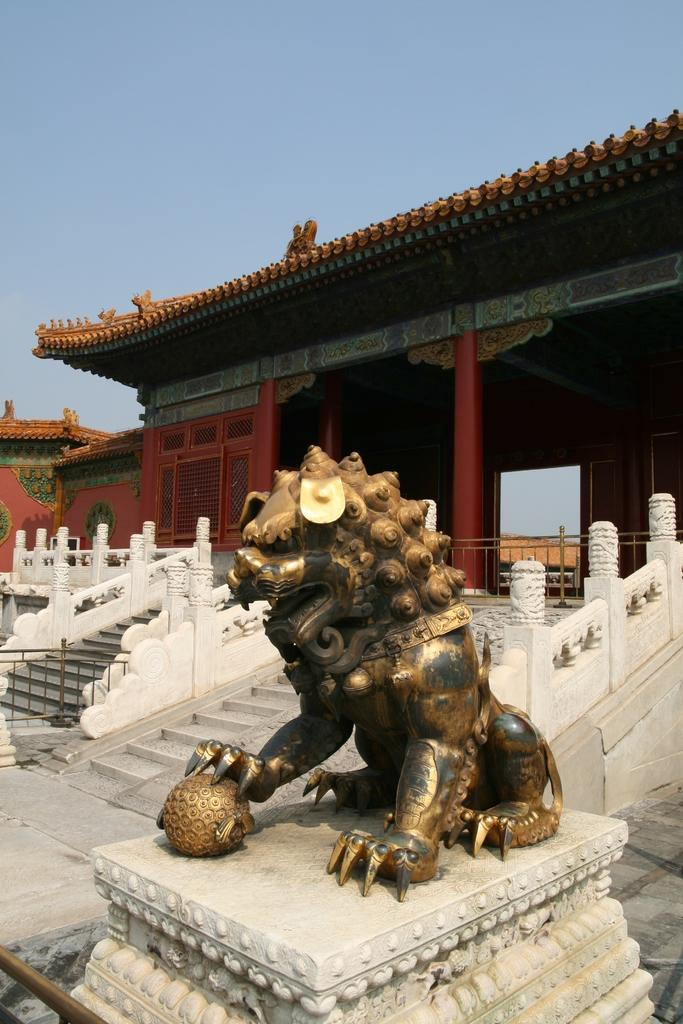What type of animal is depicted in the sculpture in the image? There is a sculpture of a lion in the image. What architectural feature can be seen in the image? There are stairs in the image. What material is used for the grilles in the image? There are iron grilles in the image. What type of structure is visible in the image? There is a building in the image. What can be seen in the background of the image? The sky is visible in the background of the image. How does the lion contribute to the wealth of the people in the image? The image does not depict any people or their wealth, and the lion is a sculpture, so it cannot contribute to anyone's wealth. 